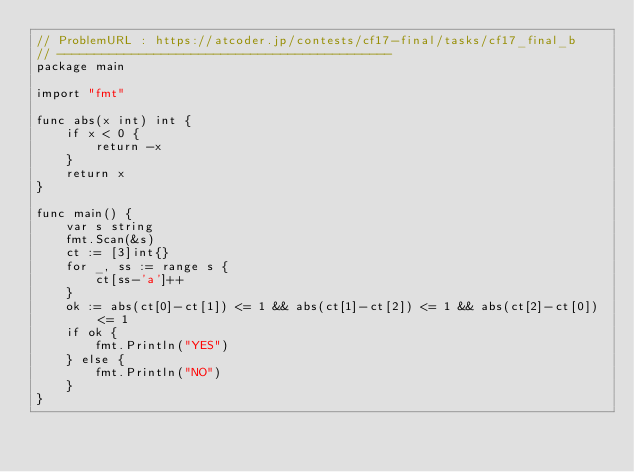Convert code to text. <code><loc_0><loc_0><loc_500><loc_500><_Go_>// ProblemURL : https://atcoder.jp/contests/cf17-final/tasks/cf17_final_b
// ---------------------------------------------
package main

import "fmt"

func abs(x int) int {
	if x < 0 {
		return -x
	}
	return x
}

func main() {
	var s string
	fmt.Scan(&s)
	ct := [3]int{}
	for _, ss := range s {
		ct[ss-'a']++
	}
	ok := abs(ct[0]-ct[1]) <= 1 && abs(ct[1]-ct[2]) <= 1 && abs(ct[2]-ct[0]) <= 1
	if ok {
		fmt.Println("YES")
	} else {
		fmt.Println("NO")
	}
}
</code> 